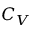<formula> <loc_0><loc_0><loc_500><loc_500>C _ { V }</formula> 